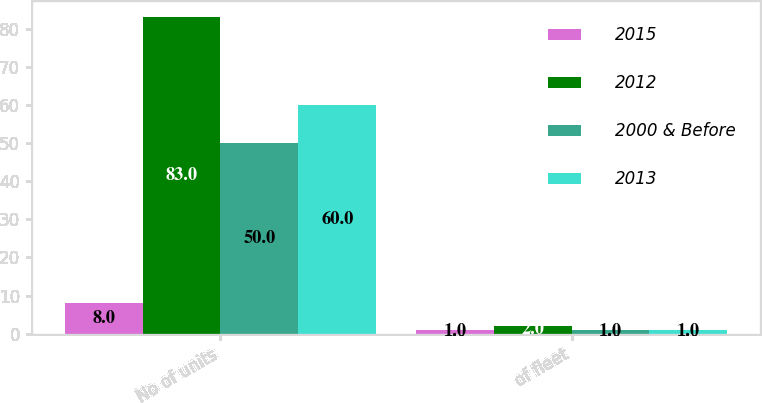<chart> <loc_0><loc_0><loc_500><loc_500><stacked_bar_chart><ecel><fcel>No of units<fcel>of fleet<nl><fcel>2015<fcel>8<fcel>1<nl><fcel>2012<fcel>83<fcel>2<nl><fcel>2000 & Before<fcel>50<fcel>1<nl><fcel>2013<fcel>60<fcel>1<nl></chart> 